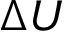<formula> <loc_0><loc_0><loc_500><loc_500>\Delta U</formula> 